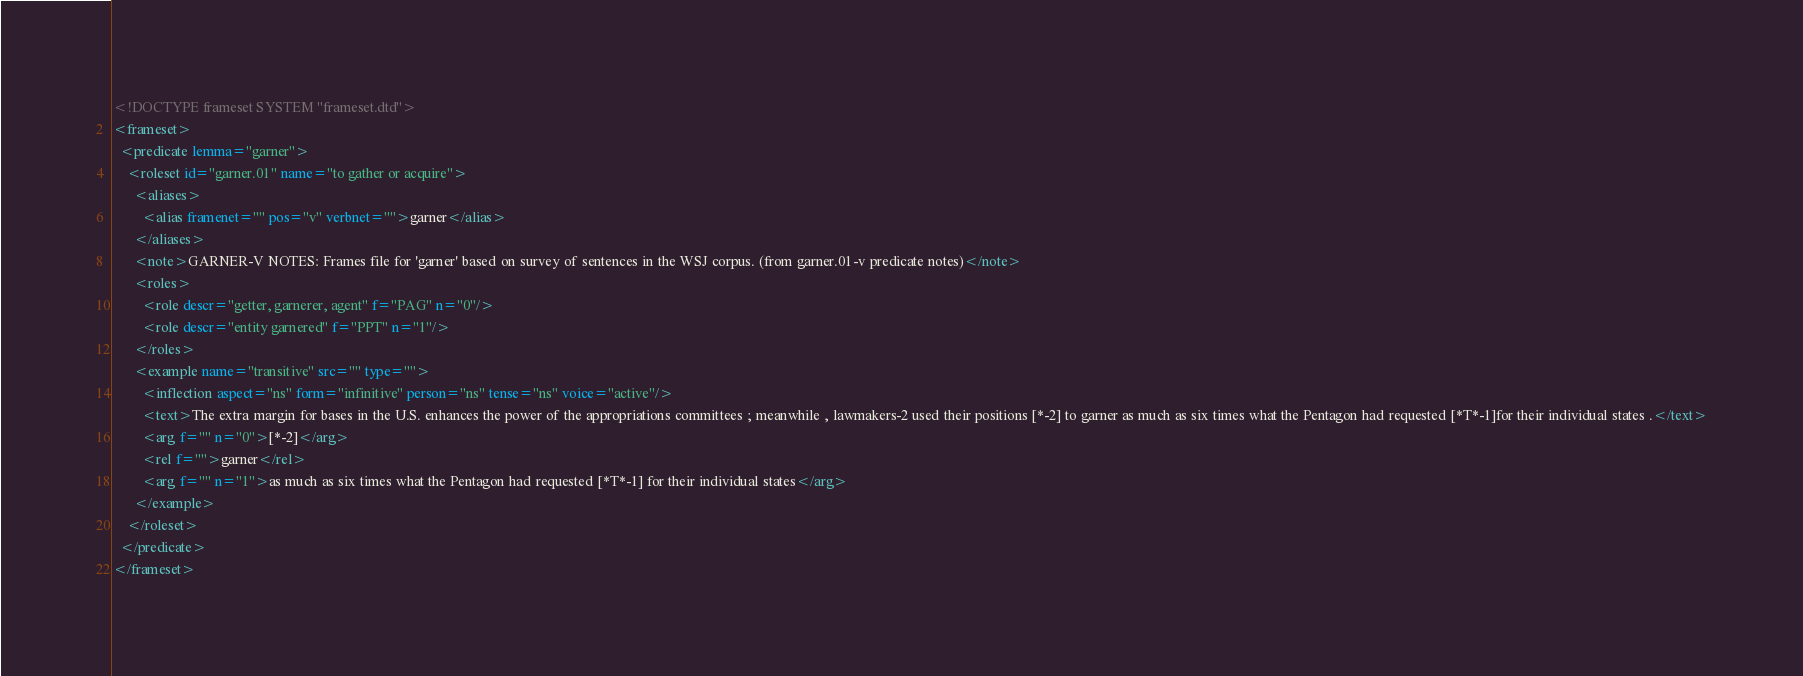<code> <loc_0><loc_0><loc_500><loc_500><_XML_><!DOCTYPE frameset SYSTEM "frameset.dtd">
<frameset>
  <predicate lemma="garner">
    <roleset id="garner.01" name="to gather or acquire">
      <aliases>
        <alias framenet="" pos="v" verbnet="">garner</alias>
      </aliases>
      <note>GARNER-V NOTES: Frames file for 'garner' based on survey of sentences in the WSJ corpus. (from garner.01-v predicate notes)</note>
      <roles>
        <role descr="getter, garnerer, agent" f="PAG" n="0"/>
        <role descr="entity garnered" f="PPT" n="1"/>
      </roles>
      <example name="transitive" src="" type="">
        <inflection aspect="ns" form="infinitive" person="ns" tense="ns" voice="active"/>
        <text>The extra margin for bases in the U.S. enhances the power of the appropriations committees ; meanwhile , lawmakers-2 used their positions [*-2] to garner as much as six times what the Pentagon had requested [*T*-1]for their individual states .</text>
        <arg f="" n="0">[*-2]</arg>
        <rel f="">garner</rel>
        <arg f="" n="1">as much as six times what the Pentagon had requested [*T*-1] for their individual states</arg>
      </example>
    </roleset>
  </predicate>
</frameset>
</code> 